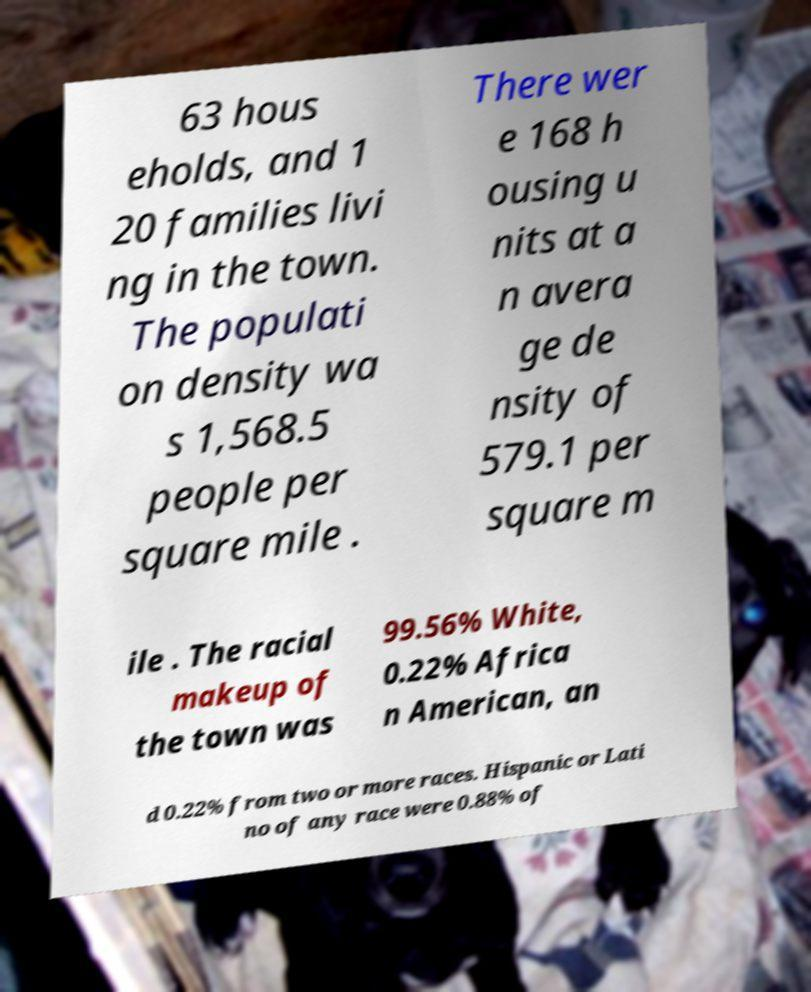Please identify and transcribe the text found in this image. 63 hous eholds, and 1 20 families livi ng in the town. The populati on density wa s 1,568.5 people per square mile . There wer e 168 h ousing u nits at a n avera ge de nsity of 579.1 per square m ile . The racial makeup of the town was 99.56% White, 0.22% Africa n American, an d 0.22% from two or more races. Hispanic or Lati no of any race were 0.88% of 